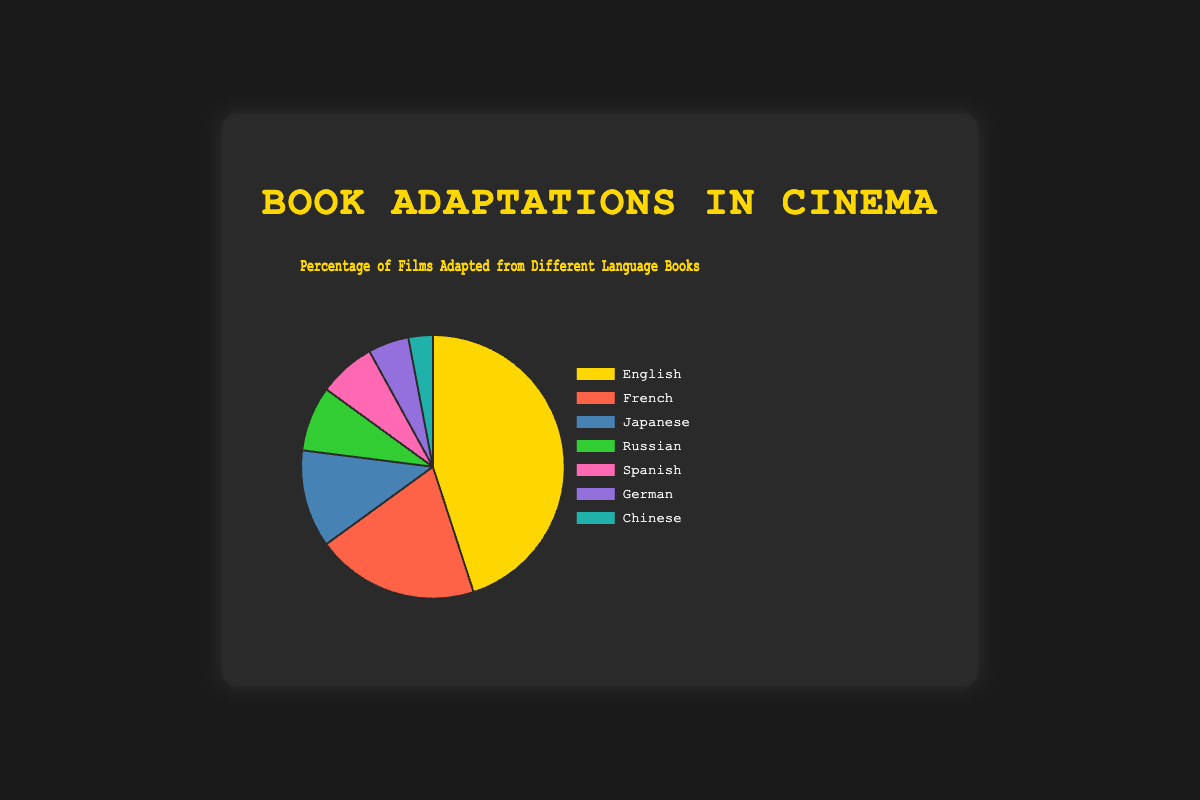what percentage of films are adapted from Japanese books? The Pie chart shows the percentage for each language. Locate the section labeled "Japanese" and read the corresponding percentage.
Answer: 12% How much higher is the percentage of films adapted from English books compared to German books? Find the percentages for English and German books. English is 45% and German is 5%. The difference is calculated as 45 - 5 = 40.
Answer: 40% Which language has the lowest percentage of film adaptations? Check the Pie chart for the section with the smallest percentage. The smallest section is labeled "Chinese" at 3%.
Answer: Chinese What is the combined percentage of films adapted from French and Spanish books? Find the percentages for French and Spanish books. French is 20% and Spanish is 7%. The combined percentage is 20 + 7 = 27%.
Answer: 27% Are there more films adapted from Russian books or Japanese books? Compare the percentages for Russian and Japanese books. Russian is 8% and Japanese is 12%. Since 12% is greater than 8%, more films are adapted from Japanese books.
Answer: Japanese Which color represents films adapted from French books? Locate the section labeled "French" and identify its color. The corresponding color for French books is red.
Answer: Red What is the total percentage of films adapted from non-European languages (Japanese, Chinese)? Find the percentages for Japanese and Chinese. Japanese is 12% and Chinese is 3%. The combined total is 12 + 3 = 15%.
Answer: 15% If 1000 films were considered, how many of them would be adapted from English books? The percentage for English books is 45%. To find the actual number: (45/100) * 1000 = 450 films.
Answer: 450 Which two languages have the closest adaptation percentages? Compare the adaptation percentages for each language. Spanish is 7% and German is 5%, making the difference 2%, which is the closest among other pairs.
Answer: Spanish and German 